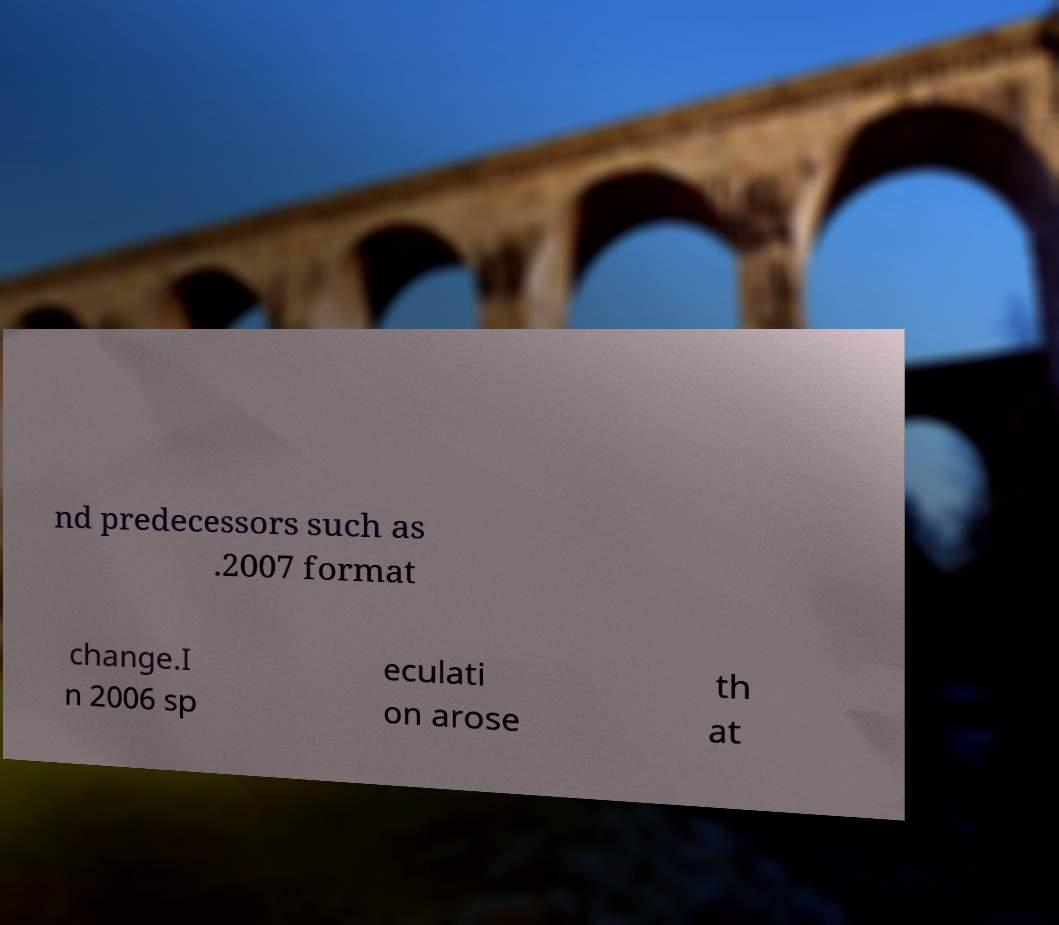Please identify and transcribe the text found in this image. nd predecessors such as .2007 format change.I n 2006 sp eculati on arose th at 